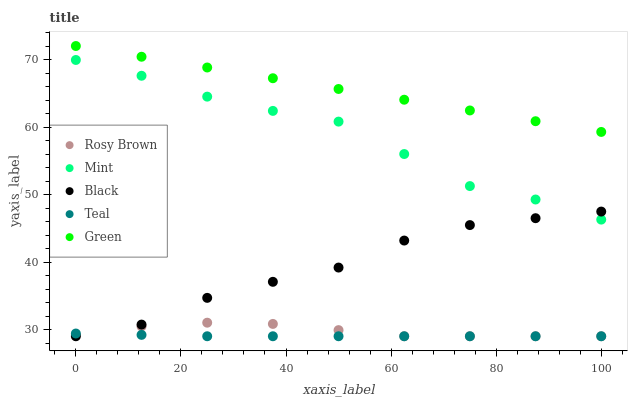Does Teal have the minimum area under the curve?
Answer yes or no. Yes. Does Green have the maximum area under the curve?
Answer yes or no. Yes. Does Rosy Brown have the minimum area under the curve?
Answer yes or no. No. Does Rosy Brown have the maximum area under the curve?
Answer yes or no. No. Is Green the smoothest?
Answer yes or no. Yes. Is Mint the roughest?
Answer yes or no. Yes. Is Rosy Brown the smoothest?
Answer yes or no. No. Is Rosy Brown the roughest?
Answer yes or no. No. Does Black have the lowest value?
Answer yes or no. Yes. Does Mint have the lowest value?
Answer yes or no. No. Does Green have the highest value?
Answer yes or no. Yes. Does Rosy Brown have the highest value?
Answer yes or no. No. Is Mint less than Green?
Answer yes or no. Yes. Is Mint greater than Teal?
Answer yes or no. Yes. Does Teal intersect Rosy Brown?
Answer yes or no. Yes. Is Teal less than Rosy Brown?
Answer yes or no. No. Is Teal greater than Rosy Brown?
Answer yes or no. No. Does Mint intersect Green?
Answer yes or no. No. 